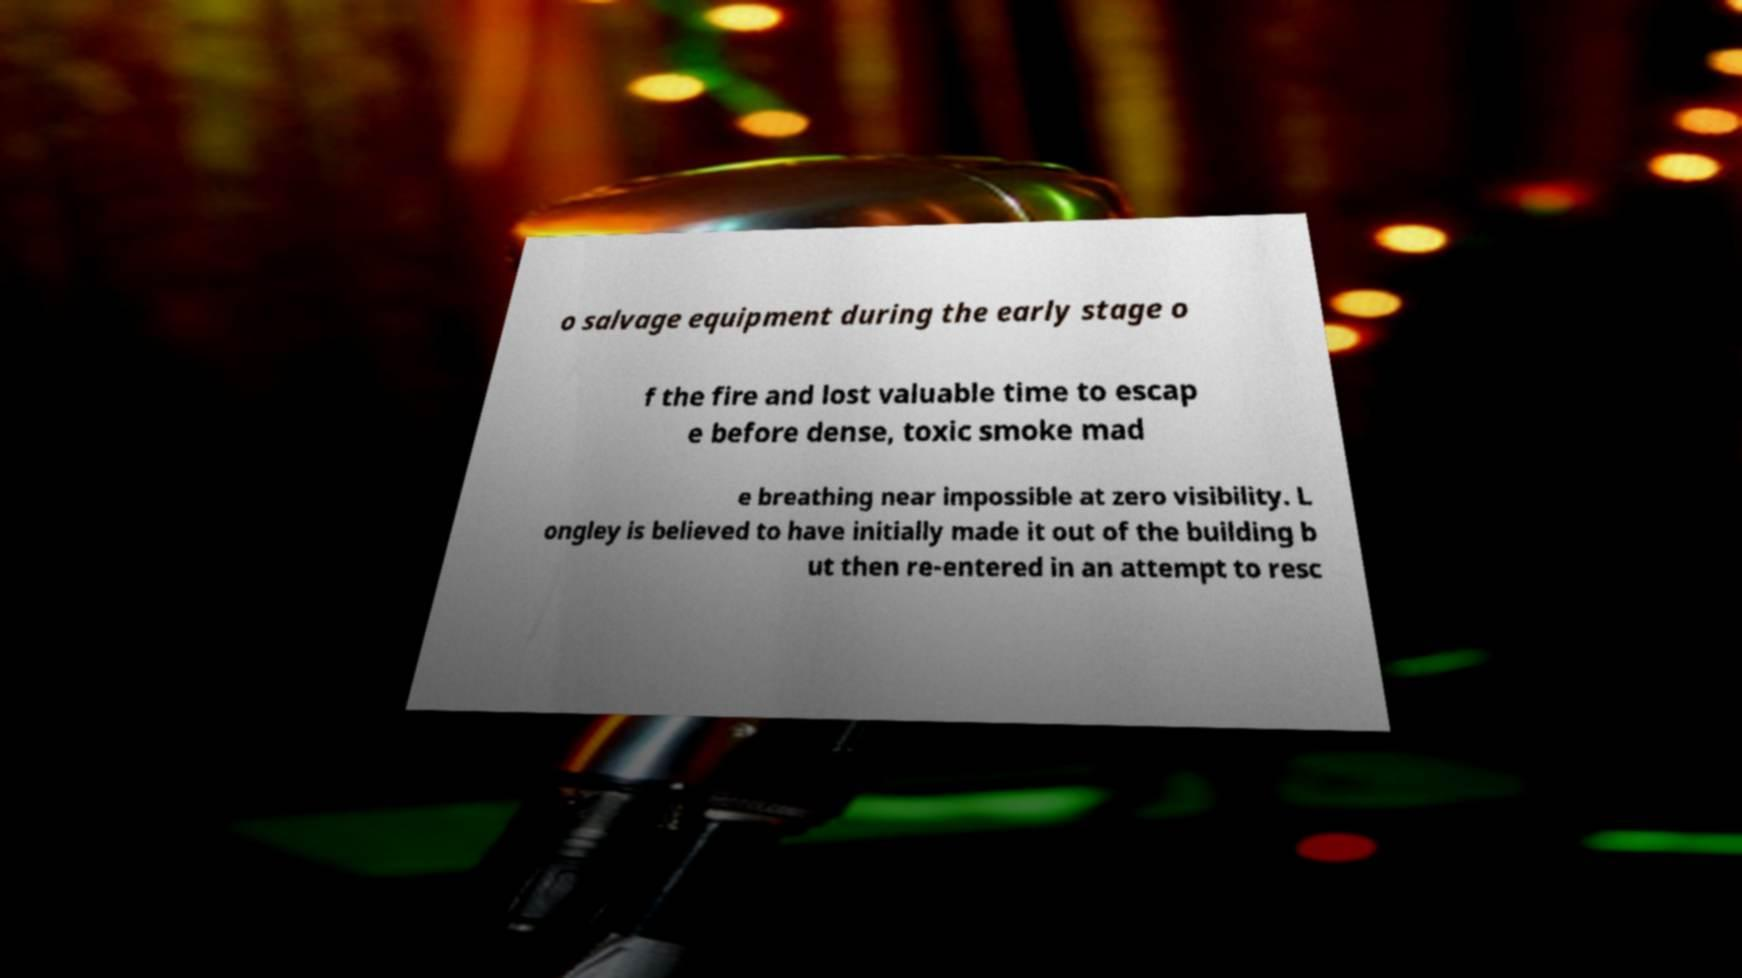Please identify and transcribe the text found in this image. o salvage equipment during the early stage o f the fire and lost valuable time to escap e before dense, toxic smoke mad e breathing near impossible at zero visibility. L ongley is believed to have initially made it out of the building b ut then re-entered in an attempt to resc 